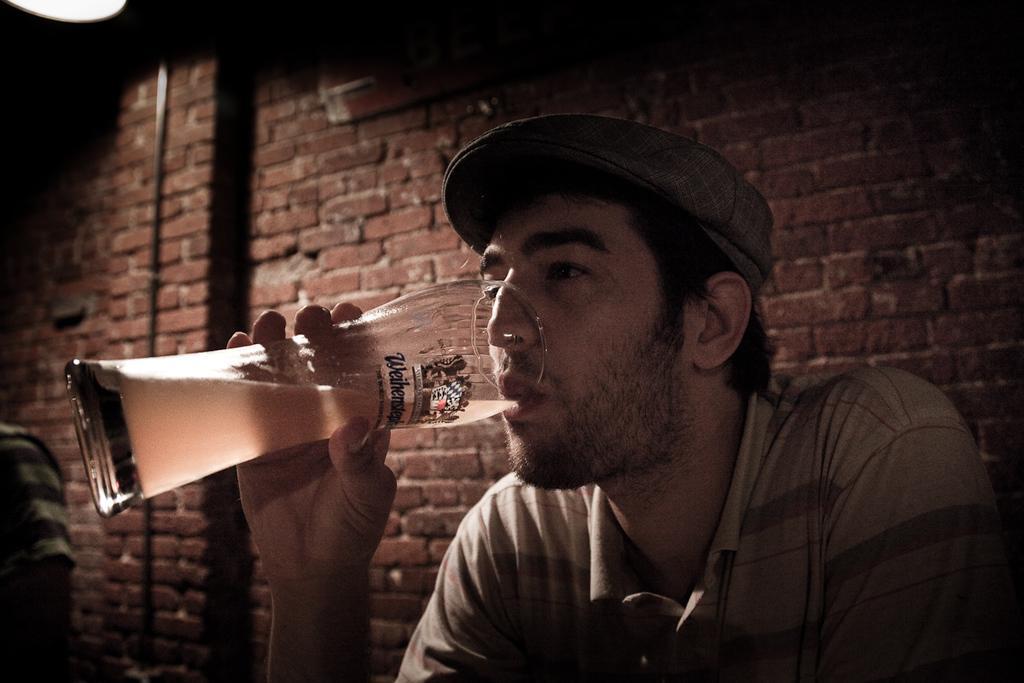In one or two sentences, can you explain what this image depicts? In the foreground of this picture we can see a man seems to be sitting, wearing t-shirt, holding a glass of drink and drinking. In the background we can see the brick wall, light. In the left corner we can see another person seems to be sitting on an object. 